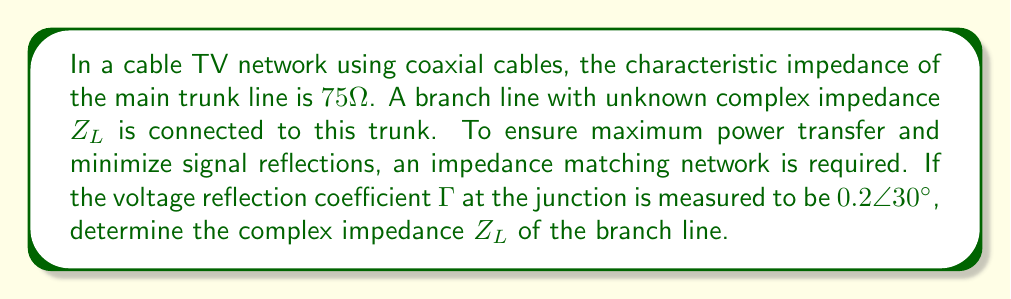Help me with this question. To solve this problem, we'll follow these steps:

1) First, recall the formula for the voltage reflection coefficient $\Gamma$:

   $$\Gamma = \frac{Z_L - Z_0}{Z_L + Z_0}$$

   where $Z_L$ is the load impedance (branch line) and $Z_0$ is the characteristic impedance (main trunk line).

2) We're given that $Z_0 = 75\Omega$ and $\Gamma = 0.2\angle 30°$. Let's convert $\Gamma$ to rectangular form:

   $$\Gamma = 0.2(\cos 30° + i\sin 30°) = 0.1732 + 0.1i$$

3) Now, let's rearrange the reflection coefficient formula to solve for $Z_L$:

   $$\Gamma(Z_L + Z_0) = Z_L - Z_0$$
   $$\Gamma Z_L + \Gamma Z_0 = Z_L - Z_0$$
   $$\Gamma Z_L - Z_L = -Z_0 - \Gamma Z_0$$
   $$Z_L(\Gamma - 1) = -Z_0(1 + \Gamma)$$
   $$Z_L = Z_0\frac{1 + \Gamma}{1 - \Gamma}$$

4) Let's substitute our known values:

   $$Z_L = 75\frac{1 + (0.1732 + 0.1i)}{1 - (0.1732 + 0.1i)}$$

5) To simplify this, let's multiply numerator and denominator by the complex conjugate of the denominator:

   $$Z_L = 75\frac{(1.1732 + 0.1i)(0.8268 - 0.1i)}{(0.8268 - 0.1i)(0.8268 - 0.1i)}$$

6) Expanding and simplifying:

   $$Z_L = 75\frac{0.9701 + 0.1732i + 0.0827i - 0.01}{0.6836 + 0.01}$$
   $$Z_L = 75\frac{0.9601 + 0.2559i}{0.6936}$$

7) Separating real and imaginary parts:

   $$Z_L = 75(\frac{0.9601}{0.6936} + i\frac{0.2559}{0.6936})$$
   $$Z_L = 103.94 + 27.67i \approx 104 + 28i\Omega$$
Answer: $Z_L \approx 104 + 28i\Omega$ 